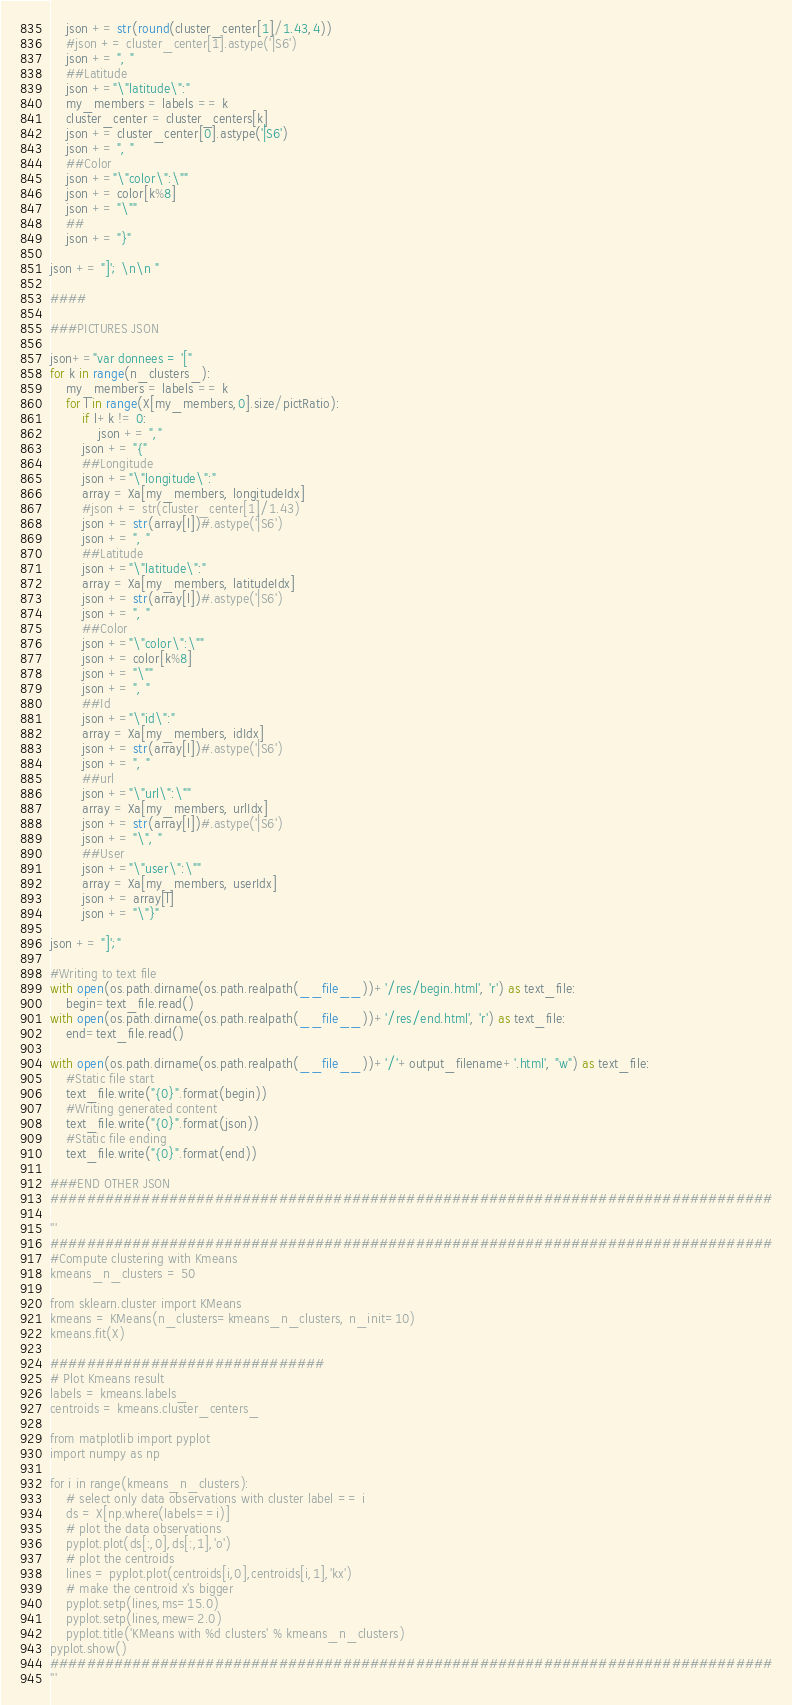Convert code to text. <code><loc_0><loc_0><loc_500><loc_500><_Python_>    json += str(round(cluster_center[1]/1.43,4))
    #json += cluster_center[1].astype('|S6')
    json += ", "
    ##Latitude
    json +="\"latitude\":"
    my_members = labels == k
    cluster_center = cluster_centers[k]
    json += cluster_center[0].astype('|S6')
    json += ", "
    ##Color
    json +="\"color\":\""
    json += color[k%8]
    json += "\""
    ##
    json += "}"
    
json += "]'; \n\n "

####

###PICTURES JSON

json+="var donnees = '["
for k in range(n_clusters_):
    my_members = labels == k
    for l in range(X[my_members,0].size/pictRatio):
        if l+k != 0:
            json += ","
        json += "{"
        ##Longitude
        json +="\"longitude\":"
        array = Xa[my_members, longitudeIdx]
        #json += str(cluster_center[1]/1.43)
        json += str(array[l])#.astype('|S6')
        json += ", "
        ##Latitude
        json +="\"latitude\":"
        array = Xa[my_members, latitudeIdx]
        json += str(array[l])#.astype('|S6')
        json += ", "
        ##Color
        json +="\"color\":\""
        json += color[k%8]
        json += "\""
        json += ", "
        ##Id
        json +="\"id\":"
        array = Xa[my_members, idIdx]
        json += str(array[l])#.astype('|S6')
        json += ", "
        ##url
        json +="\"url\":\""
        array = Xa[my_members, urlIdx]
        json += str(array[l])#.astype('|S6')
        json += "\", "
        ##User
        json +="\"user\":\""
        array = Xa[my_members, userIdx]
        json += array[l]
        json += "\"}"

json += "]';"

#Writing to text file
with open(os.path.dirname(os.path.realpath(__file__))+'/res/begin.html', 'r') as text_file:
    begin=text_file.read()
with open(os.path.dirname(os.path.realpath(__file__))+'/res/end.html', 'r') as text_file:
    end=text_file.read()

with open(os.path.dirname(os.path.realpath(__file__))+'/'+output_filename+'.html', "w") as text_file:
    #Static file start
    text_file.write("{0}".format(begin))
    #Writing generated content
    text_file.write("{0}".format(json))
    #Static file ending
    text_file.write("{0}".format(end))
    
###END OTHER JSON
###############################################################################

'''
###############################################################################
#Compute clustering with Kmeans
kmeans_n_clusters = 50

from sklearn.cluster import KMeans
kmeans = KMeans(n_clusters=kmeans_n_clusters, n_init=10)
kmeans.fit(X)

##############################
# Plot Kmeans result
labels = kmeans.labels_
centroids = kmeans.cluster_centers_

from matplotlib import pyplot
import numpy as np

for i in range(kmeans_n_clusters):
    # select only data observations with cluster label == i
    ds = X[np.where(labels==i)]
    # plot the data observations
    pyplot.plot(ds[:,0],ds[:,1],'o')
    # plot the centroids
    lines = pyplot.plot(centroids[i,0],centroids[i,1],'kx')
    # make the centroid x's bigger
    pyplot.setp(lines,ms=15.0)
    pyplot.setp(lines,mew=2.0)
    pyplot.title('KMeans with %d clusters' % kmeans_n_clusters)
pyplot.show()
###############################################################################
'''</code> 